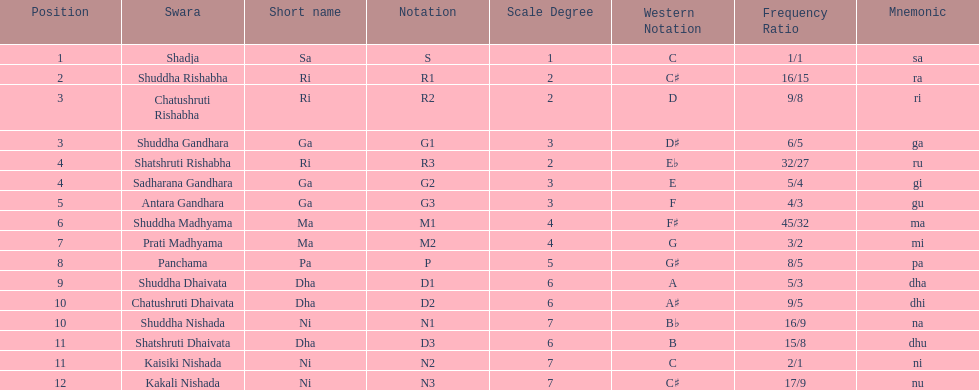Other than m1 how many notations have "1" in them? 4. 